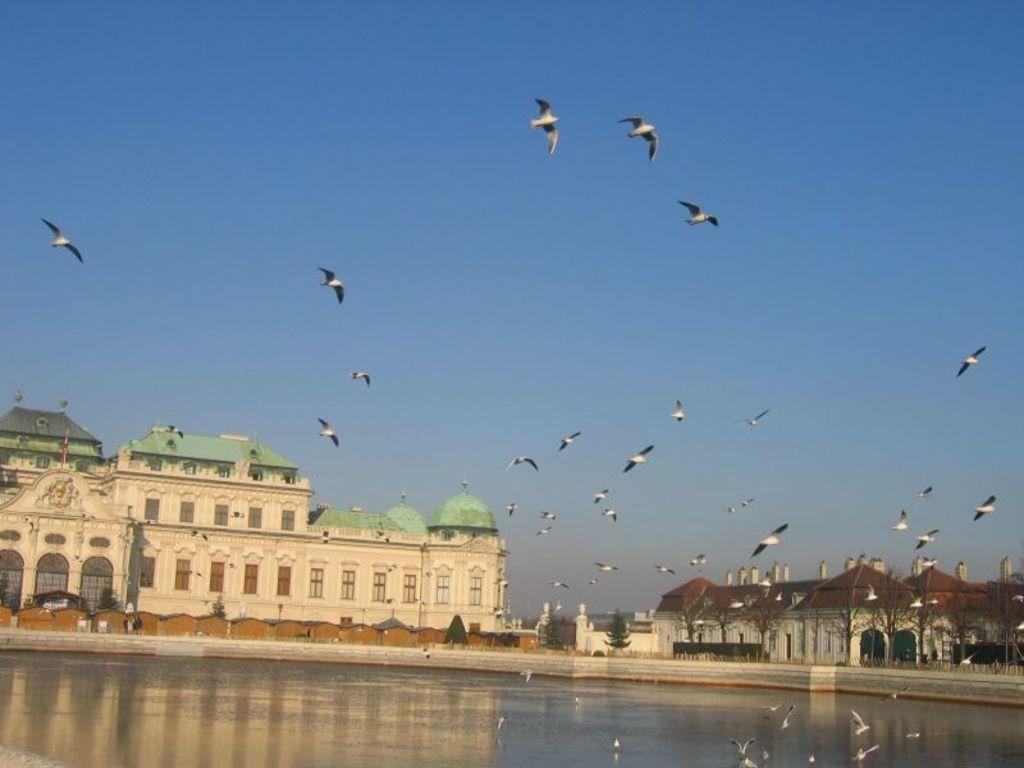What is happening in the sky in the image? Birds are flying in the sky in the image. What can be seen below the sky in the image? There is water visible in the image, as well as buildings and trees. What is the color of the sky in the image? The sky is blue in the image. What type of suit is the bird wearing in the image? There are no birds wearing suits in the image, as birds do not wear clothing. What message of peace can be seen in the image? There is no message of peace present in the image; it simply shows birds flying in the sky, water, buildings, and trees. 